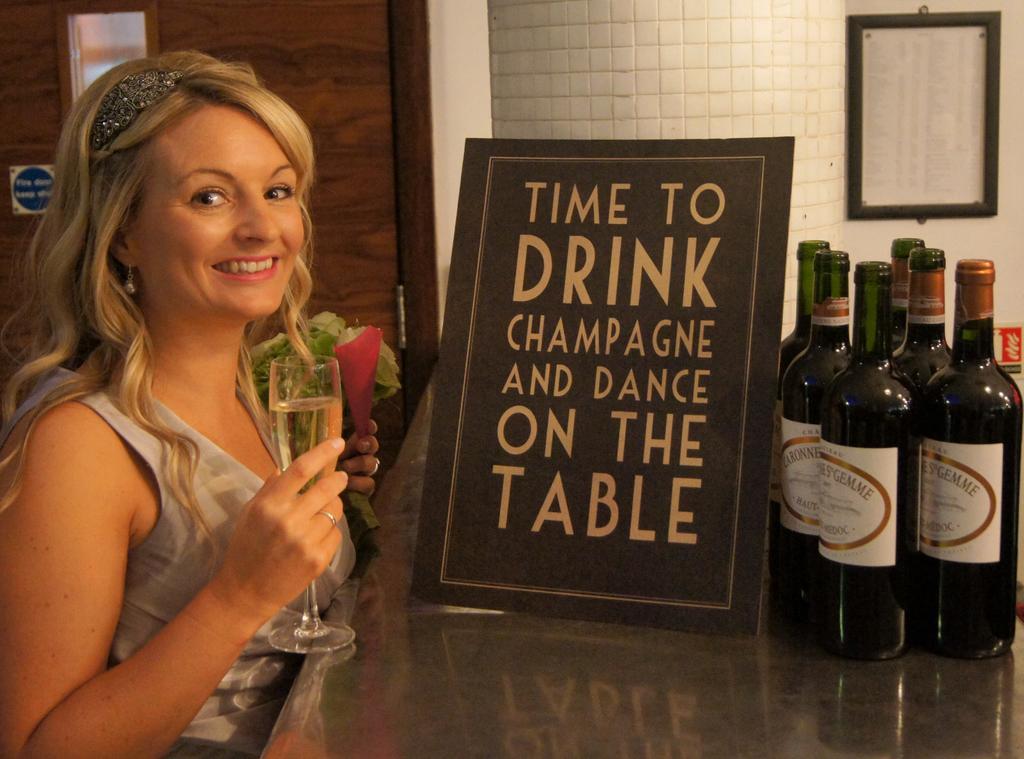Could you give a brief overview of what you see in this image? In this picture there is a woman holding a wine glass in her hand and smiling in front of the table on which a wine bottles were placed and a quote was framed here. In the background there is a wall to which a photo frame was attached. 